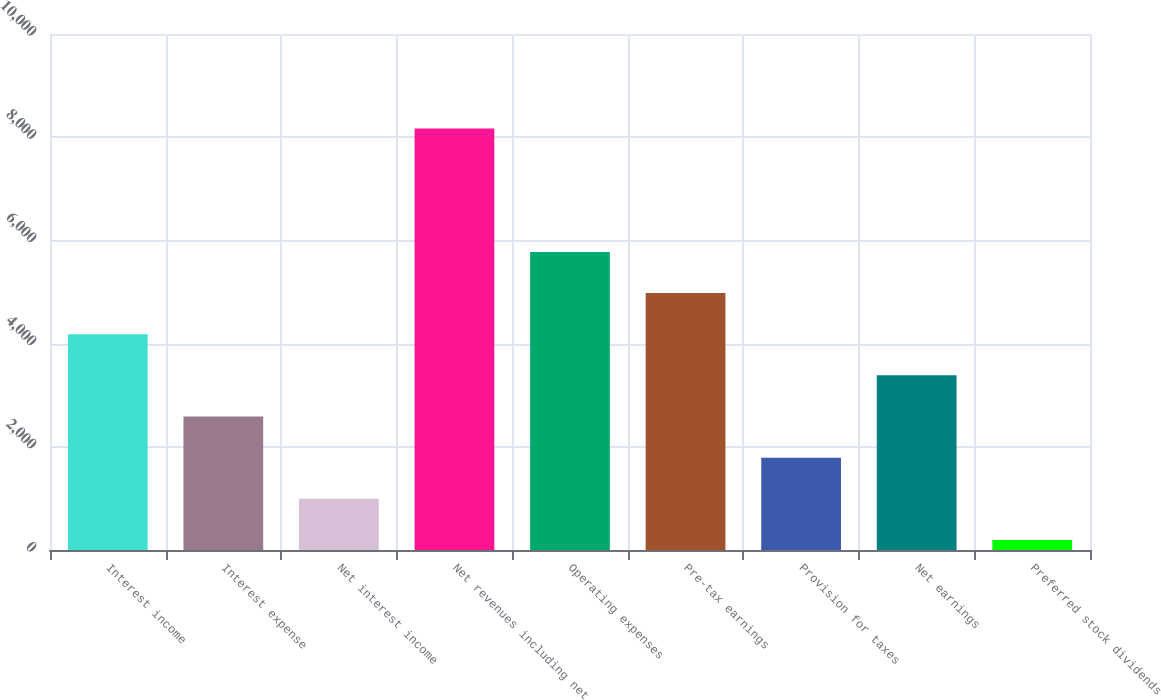<chart> <loc_0><loc_0><loc_500><loc_500><bar_chart><fcel>Interest income<fcel>Interest expense<fcel>Net interest income<fcel>Net revenues including net<fcel>Operating expenses<fcel>Pre-tax earnings<fcel>Provision for taxes<fcel>Net earnings<fcel>Preferred stock dividends<nl><fcel>4182<fcel>2586.8<fcel>991.6<fcel>8170<fcel>5777.2<fcel>4979.6<fcel>1789.2<fcel>3384.4<fcel>194<nl></chart> 